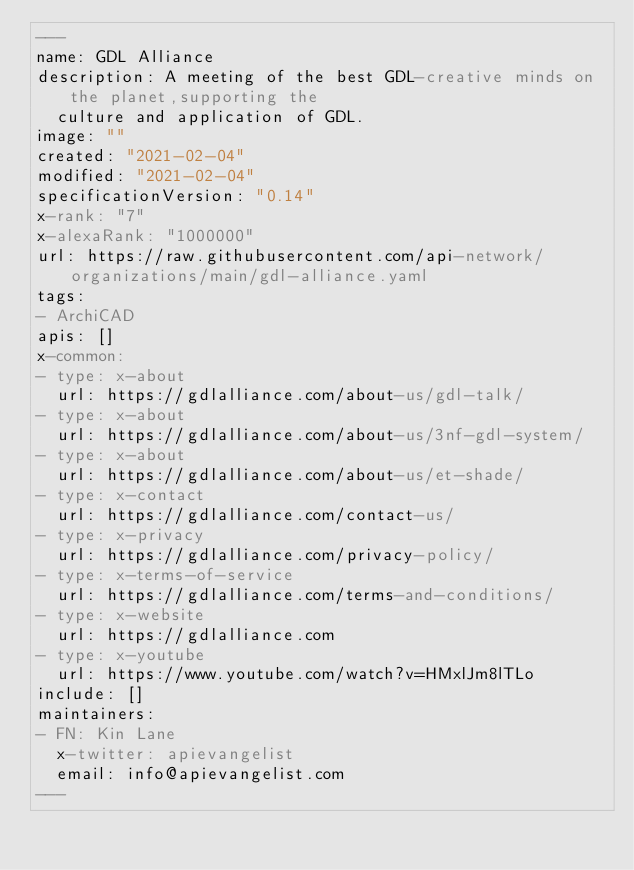Convert code to text. <code><loc_0><loc_0><loc_500><loc_500><_YAML_>---
name: GDL Alliance
description: A meeting of the best GDL-creative minds on the planet,supporting the
  culture and application of GDL.
image: ""
created: "2021-02-04"
modified: "2021-02-04"
specificationVersion: "0.14"
x-rank: "7"
x-alexaRank: "1000000"
url: https://raw.githubusercontent.com/api-network/organizations/main/gdl-alliance.yaml
tags:
- ArchiCAD
apis: []
x-common:
- type: x-about
  url: https://gdlalliance.com/about-us/gdl-talk/
- type: x-about
  url: https://gdlalliance.com/about-us/3nf-gdl-system/
- type: x-about
  url: https://gdlalliance.com/about-us/et-shade/
- type: x-contact
  url: https://gdlalliance.com/contact-us/
- type: x-privacy
  url: https://gdlalliance.com/privacy-policy/
- type: x-terms-of-service
  url: https://gdlalliance.com/terms-and-conditions/
- type: x-website
  url: https://gdlalliance.com
- type: x-youtube
  url: https://www.youtube.com/watch?v=HMxlJm8lTLo
include: []
maintainers:
- FN: Kin Lane
  x-twitter: apievangelist
  email: info@apievangelist.com
---</code> 